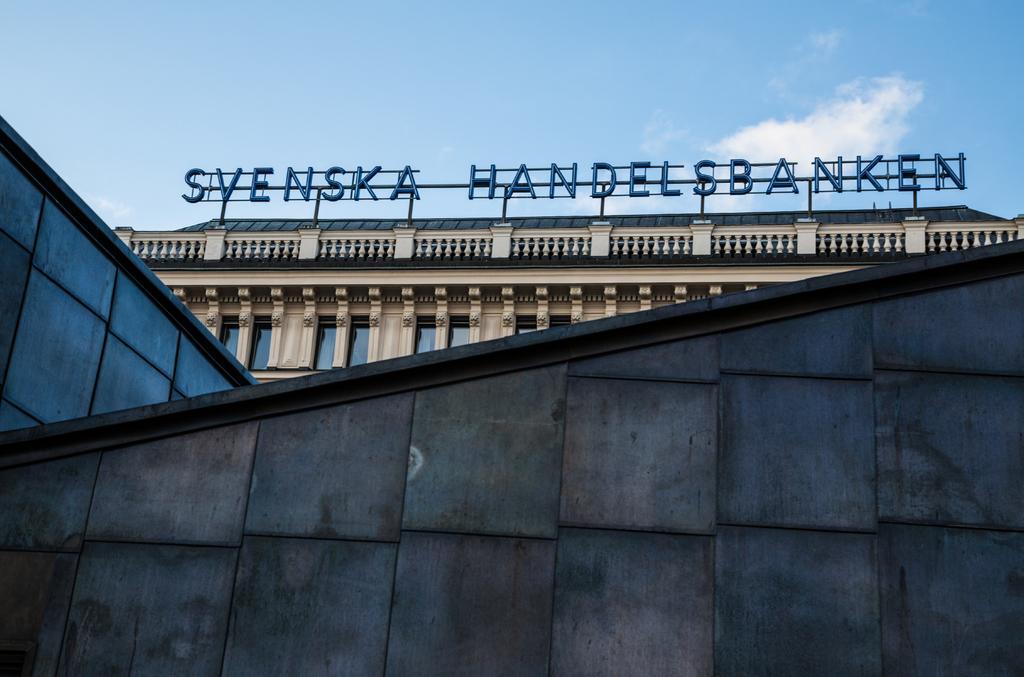Please provide a concise description of this image. In this image I can see buildings. Here I can see some names on the building. In the background I can see the sky. Here I can see a wall. 